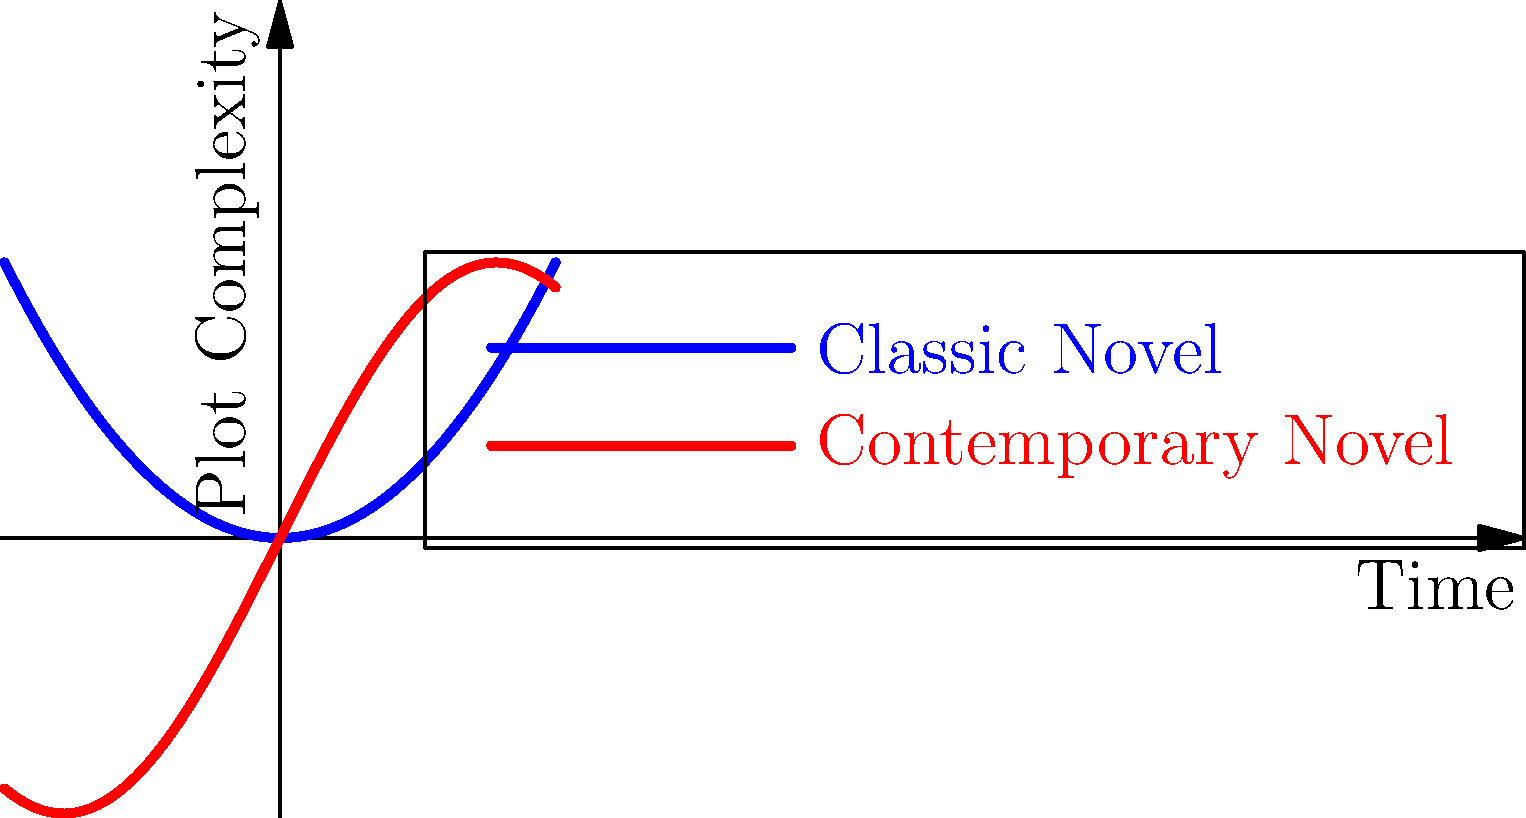Based on the graph, which narrative structure typically demonstrates more frequent fluctuations in plot complexity over time? To answer this question, let's analyze the two curves in the graph:

1. The blue curve represents the narrative structure of a classic novel. It shows a smooth, gradually increasing parabolic shape.

2. The red curve represents the narrative structure of a contemporary novel. It displays a sinusoidal pattern with more frequent ups and downs.

3. Plot complexity is represented on the y-axis, while time progression is on the x-axis.

4. The classic novel's curve (blue) shows a steady increase in complexity over time, with minimal fluctuations.

5. The contemporary novel's curve (red) exhibits regular oscillations, indicating frequent changes in plot complexity throughout the narrative.

6. These oscillations in the red curve suggest that the contemporary novel's narrative structure has more frequent shifts between simpler and more complex plot elements.

Therefore, based on this visual representation, the contemporary novel demonstrates more frequent fluctuations in plot complexity over time compared to the classic novel.
Answer: Contemporary Novel 